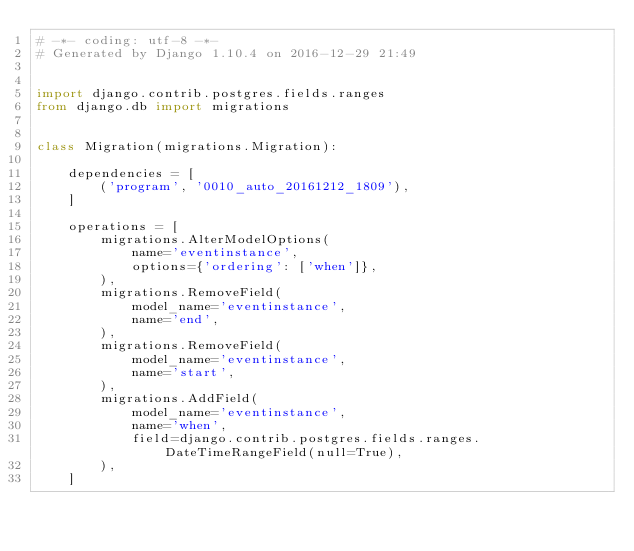Convert code to text. <code><loc_0><loc_0><loc_500><loc_500><_Python_># -*- coding: utf-8 -*-
# Generated by Django 1.10.4 on 2016-12-29 21:49


import django.contrib.postgres.fields.ranges
from django.db import migrations


class Migration(migrations.Migration):

    dependencies = [
        ('program', '0010_auto_20161212_1809'),
    ]

    operations = [
        migrations.AlterModelOptions(
            name='eventinstance',
            options={'ordering': ['when']},
        ),
        migrations.RemoveField(
            model_name='eventinstance',
            name='end',
        ),
        migrations.RemoveField(
            model_name='eventinstance',
            name='start',
        ),
        migrations.AddField(
            model_name='eventinstance',
            name='when',
            field=django.contrib.postgres.fields.ranges.DateTimeRangeField(null=True),
        ),
    ]
</code> 